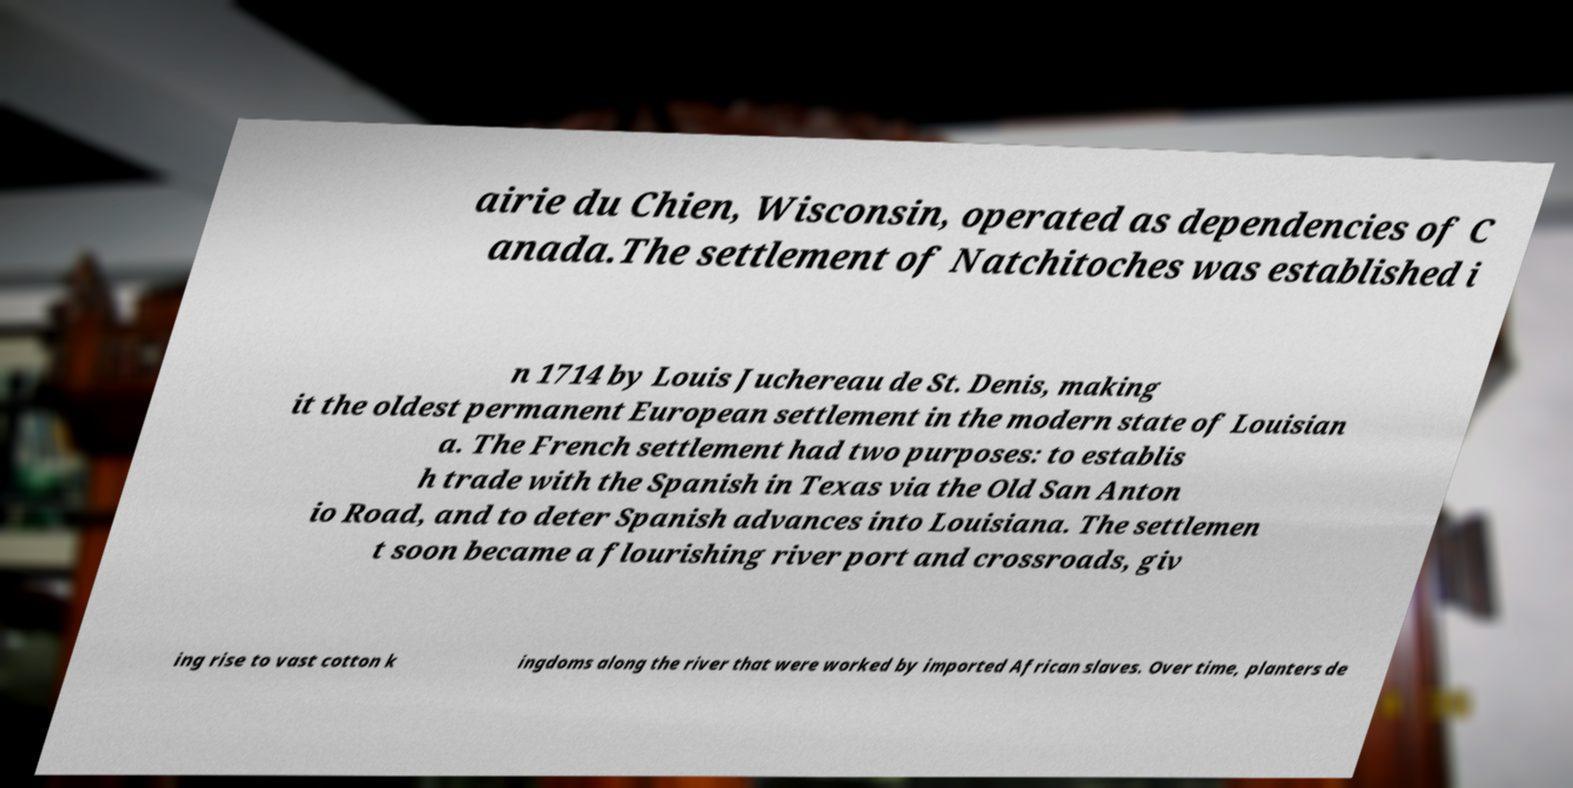Please identify and transcribe the text found in this image. airie du Chien, Wisconsin, operated as dependencies of C anada.The settlement of Natchitoches was established i n 1714 by Louis Juchereau de St. Denis, making it the oldest permanent European settlement in the modern state of Louisian a. The French settlement had two purposes: to establis h trade with the Spanish in Texas via the Old San Anton io Road, and to deter Spanish advances into Louisiana. The settlemen t soon became a flourishing river port and crossroads, giv ing rise to vast cotton k ingdoms along the river that were worked by imported African slaves. Over time, planters de 